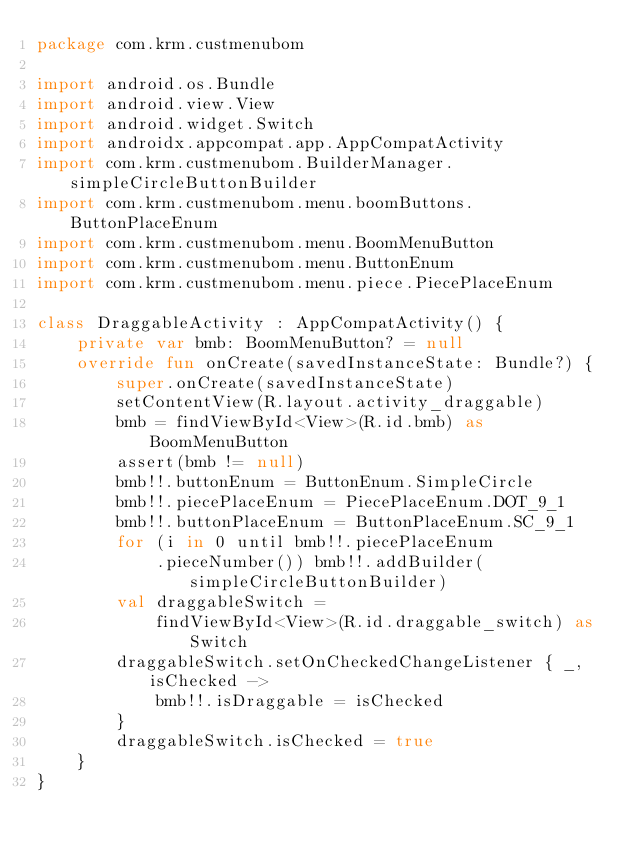<code> <loc_0><loc_0><loc_500><loc_500><_Kotlin_>package com.krm.custmenubom

import android.os.Bundle
import android.view.View
import android.widget.Switch
import androidx.appcompat.app.AppCompatActivity
import com.krm.custmenubom.BuilderManager.simpleCircleButtonBuilder
import com.krm.custmenubom.menu.boomButtons.ButtonPlaceEnum
import com.krm.custmenubom.menu.BoomMenuButton
import com.krm.custmenubom.menu.ButtonEnum
import com.krm.custmenubom.menu.piece.PiecePlaceEnum

class DraggableActivity : AppCompatActivity() {
    private var bmb: BoomMenuButton? = null
    override fun onCreate(savedInstanceState: Bundle?) {
        super.onCreate(savedInstanceState)
        setContentView(R.layout.activity_draggable)
        bmb = findViewById<View>(R.id.bmb) as BoomMenuButton
        assert(bmb != null)
        bmb!!.buttonEnum = ButtonEnum.SimpleCircle
        bmb!!.piecePlaceEnum = PiecePlaceEnum.DOT_9_1
        bmb!!.buttonPlaceEnum = ButtonPlaceEnum.SC_9_1
        for (i in 0 until bmb!!.piecePlaceEnum
            .pieceNumber()) bmb!!.addBuilder(simpleCircleButtonBuilder)
        val draggableSwitch =
            findViewById<View>(R.id.draggable_switch) as Switch
        draggableSwitch.setOnCheckedChangeListener { _, isChecked ->
            bmb!!.isDraggable = isChecked
        }
        draggableSwitch.isChecked = true
    }
}</code> 